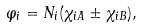<formula> <loc_0><loc_0><loc_500><loc_500>\varphi _ { i } = N _ { i } ( \chi _ { i A } \pm \chi _ { i B } ) ,</formula> 